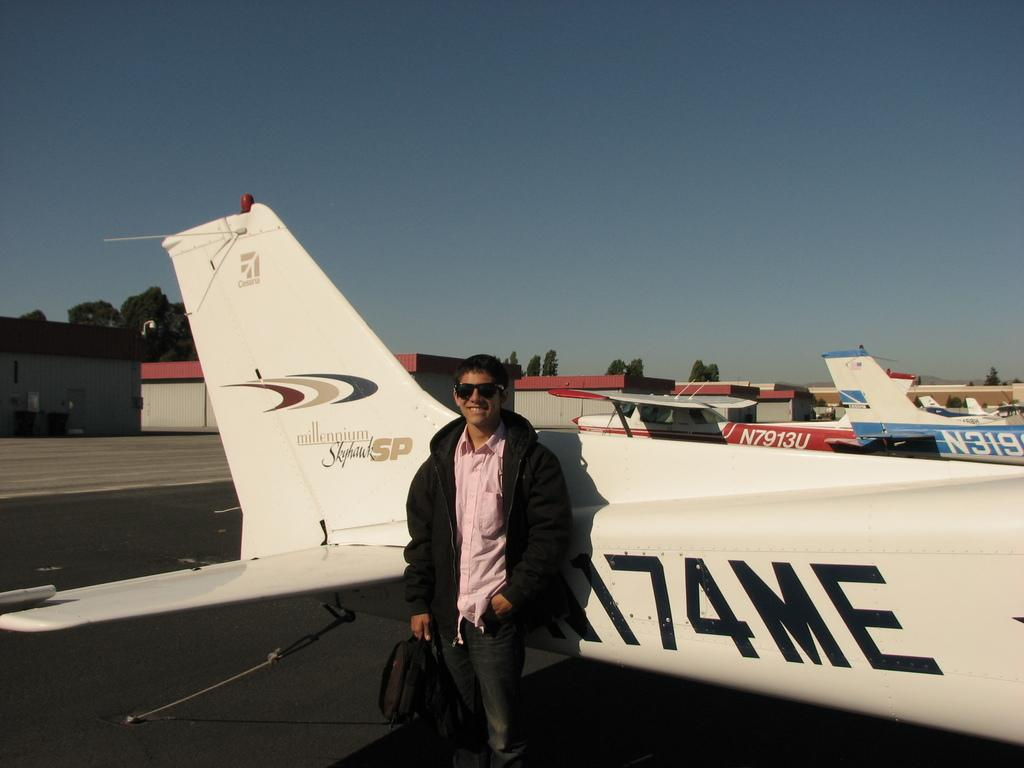What is the color of the sky in the image? The sky is blue in the image. What can be seen in the sky in the image? There are planes in the sky in the image. What structures are visible in the image? There are buildings and trees in the image. What is the person in front of the plane doing? The person is holding a bag. How does the person twist the train in the image? There is no train present in the image, so the person cannot twist a train. 